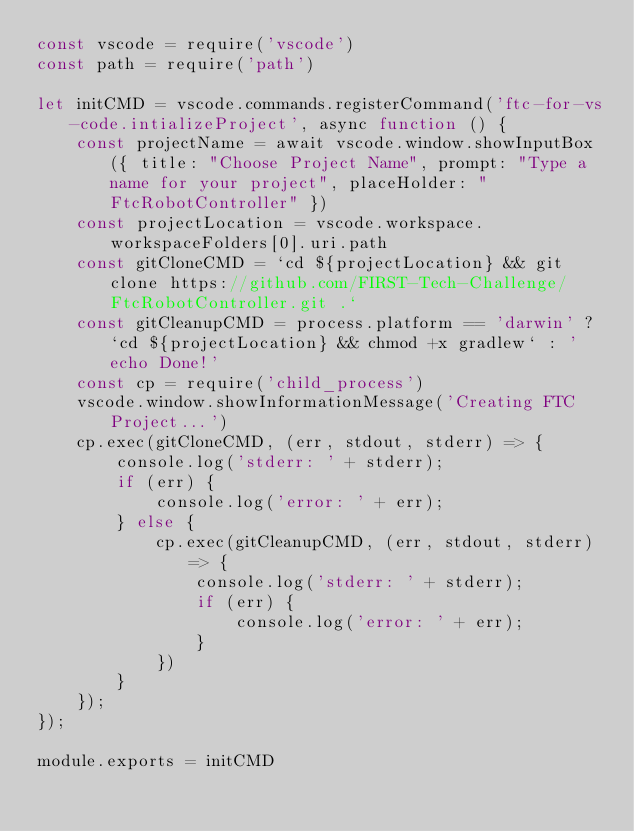Convert code to text. <code><loc_0><loc_0><loc_500><loc_500><_JavaScript_>const vscode = require('vscode')
const path = require('path')

let initCMD = vscode.commands.registerCommand('ftc-for-vs-code.intializeProject', async function () {
    const projectName = await vscode.window.showInputBox({ title: "Choose Project Name", prompt: "Type a name for your project", placeHolder: "FtcRobotController" })
    const projectLocation = vscode.workspace.workspaceFolders[0].uri.path
    const gitCloneCMD = `cd ${projectLocation} && git clone https://github.com/FIRST-Tech-Challenge/FtcRobotController.git .`
    const gitCleanupCMD = process.platform == 'darwin' ? `cd ${projectLocation} && chmod +x gradlew` : 'echo Done!'
    const cp = require('child_process')
    vscode.window.showInformationMessage('Creating FTC Project...')
    cp.exec(gitCloneCMD, (err, stdout, stderr) => {
        console.log('stderr: ' + stderr);
        if (err) {
            console.log('error: ' + err);
        } else {
            cp.exec(gitCleanupCMD, (err, stdout, stderr) => {
                console.log('stderr: ' + stderr);
                if (err) {
                    console.log('error: ' + err);
                }
            })
        }
    });
});

module.exports = initCMD</code> 